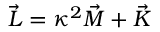Convert formula to latex. <formula><loc_0><loc_0><loc_500><loc_500>\vec { L } = \kappa ^ { 2 } \vec { M } + \vec { K }</formula> 